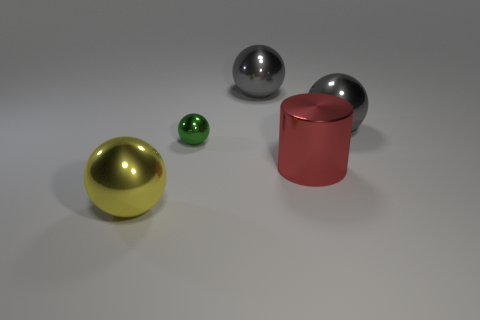The gray object that is on the left side of the large gray ball that is on the right side of the large red metal cylinder in front of the small green object is made of what material? The gray object mentioned, which appears to the left of the large gray sphere and to the right of the large red metal cylinder, is also made of metal, likely steel or aluminum, as suggested by its reflective surface and consistent with the materials of the other objects in the image. 